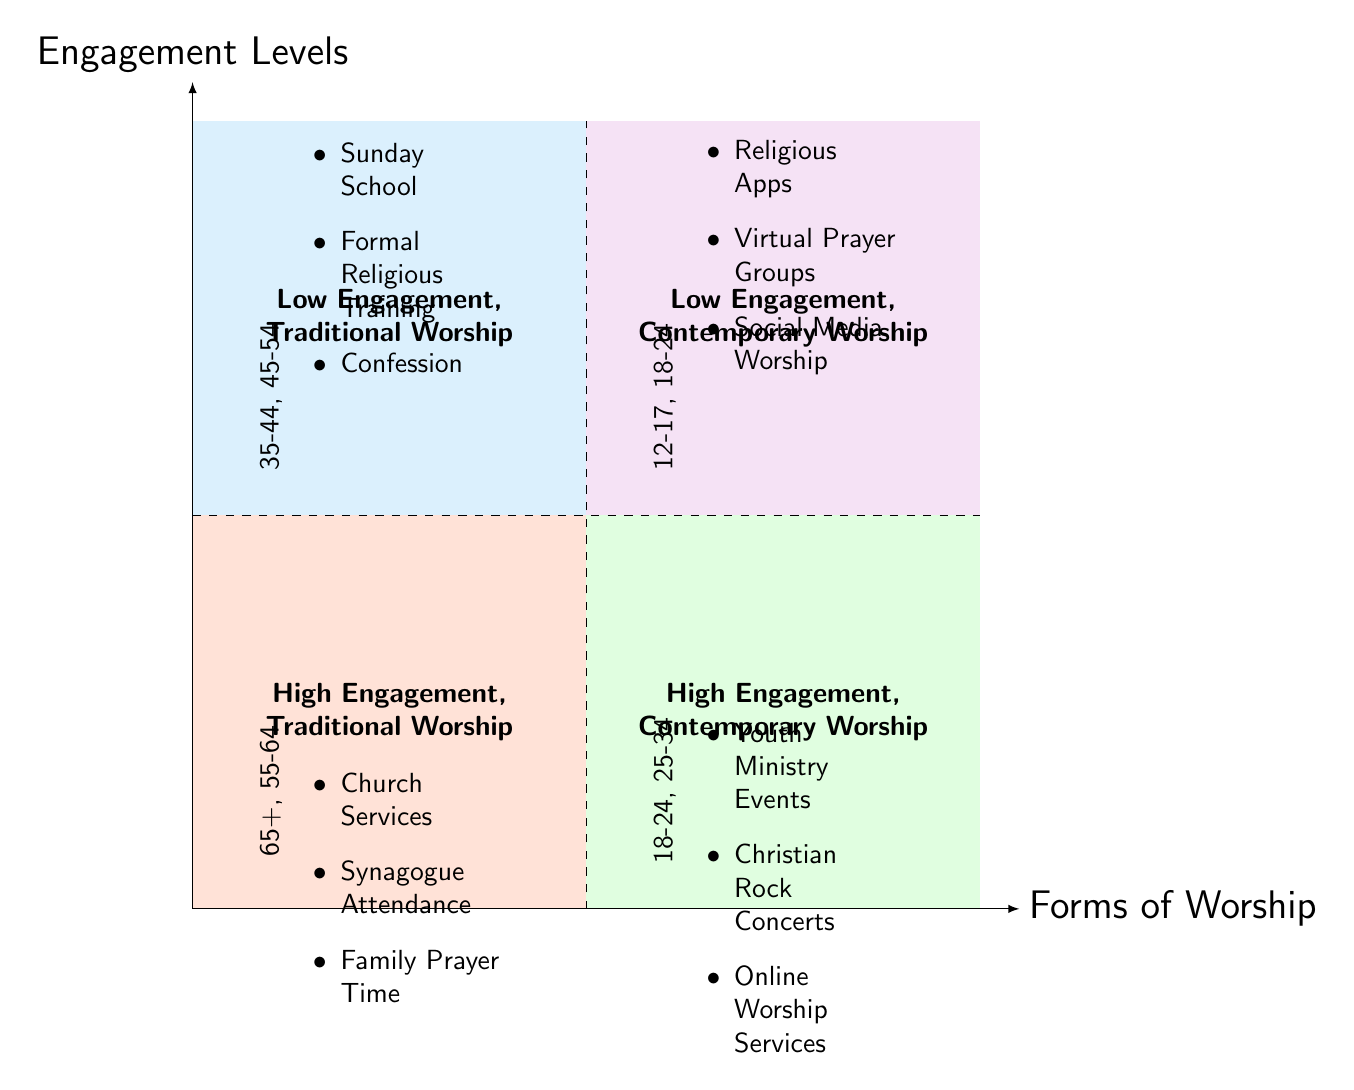What age groups are included in high engagement, traditional worship? The high engagement, traditional worship quadrant mentions the age groups of 65+ and 55-64. These are located in the lower left quadrant of the diagram.
Answer: 65+, 55-64 Which forms of worship are associated with low engagement, traditional worship? In the low engagement, traditional worship quadrant, the forms of worship listed include Sunday School, Formal Religious Training, and Confession. These are found in the lower left quadrant.
Answer: Sunday School, Formal Religious Training, Confession How many age groups fall under low engagement, contemporary worship? The low engagement, contemporary worship quadrant includes two age groups: 12-17 and 18-24. By counting these listed age groups, we determine the total is two.
Answer: 2 What is the engagement level for 18-24 year-olds in contemporary worship? The 18-24 year-olds appear in both the high engagement, contemporary worship circle and the low engagement, contemporary worship circle. However, their primary classification in the contemporary quadrant shows them associated with high engagement.
Answer: High Engagement Identify the forms of worship for the age group 65+. The age group of 65+ is associated with the forms of worship such as Church Services, Synagogue Attendance, and Family Prayer Time, which are referenced in the high engagement, traditional worship quadrant.
Answer: Church Services, Synagogue Attendance, Family Prayer Time Which quadrant contains the highest engagement levels? The upper quadrants represent higher engagement levels; thus, the quadrants "High Engagement, Traditional Worship" and "High Engagement, Contemporary Worship" both indicate high engagement levels.
Answer: High Engagement, Traditional Worship; High Engagement, Contemporary Worship What is the demographic age group for "Virtual Prayer Groups"? The form of worship "Virtual Prayer Groups" falls under the low engagement, contemporary worship quadrant, which includes 12-17 and 18-24 age groups. Therefore, it relates to these age demographics.
Answer: 12-17, 18-24 Which quadrant would you find "Christian Rock Concerts"? "Christian Rock Concerts" is found in the high engagement, contemporary worship quadrant. This is indicated in the upper right section of the diagram.
Answer: High Engagement, Contemporary Worship 